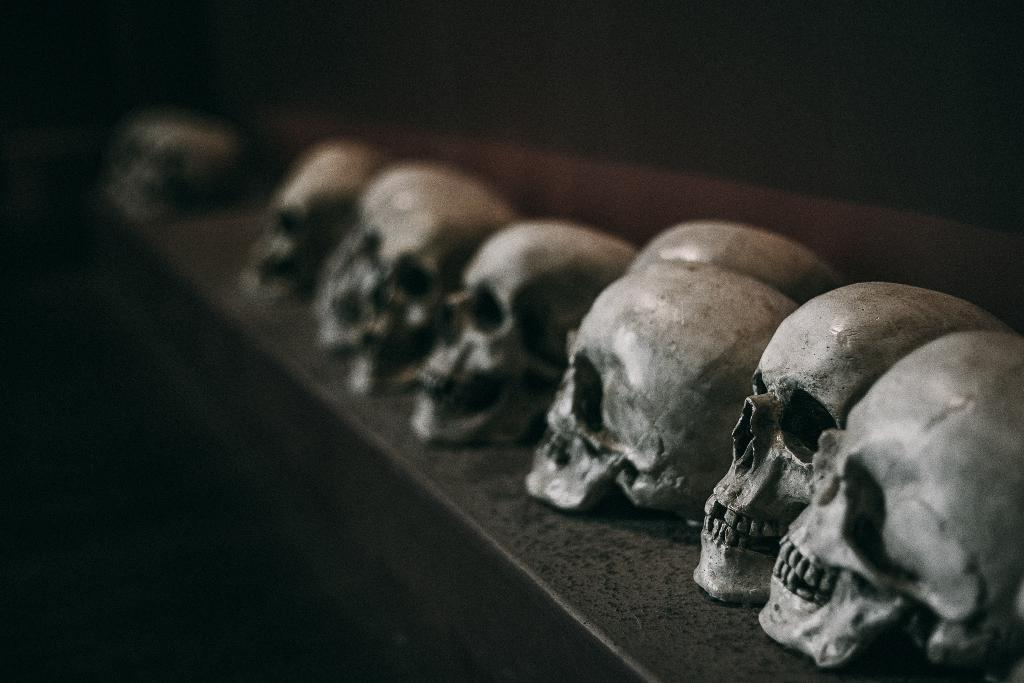What objects are present in the image? There are skulls in the image. What is the color of the skulls? The skulls are in white color. Where are the skulls located? The skulls are on some surface. What type of whip can be seen in the image? There is no whip present in the image; it only features skulls on a surface. 